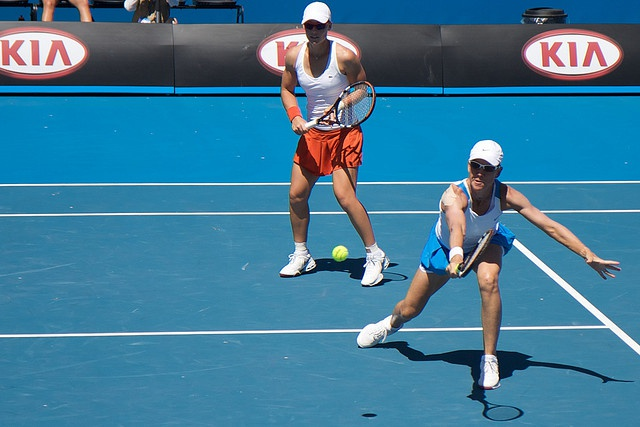Describe the objects in this image and their specific colors. I can see people in black, teal, and white tones, people in black, white, maroon, and brown tones, tennis racket in black, gray, and ivory tones, people in black, lightgray, gray, and maroon tones, and tennis racket in black, gray, darkgray, and tan tones in this image. 